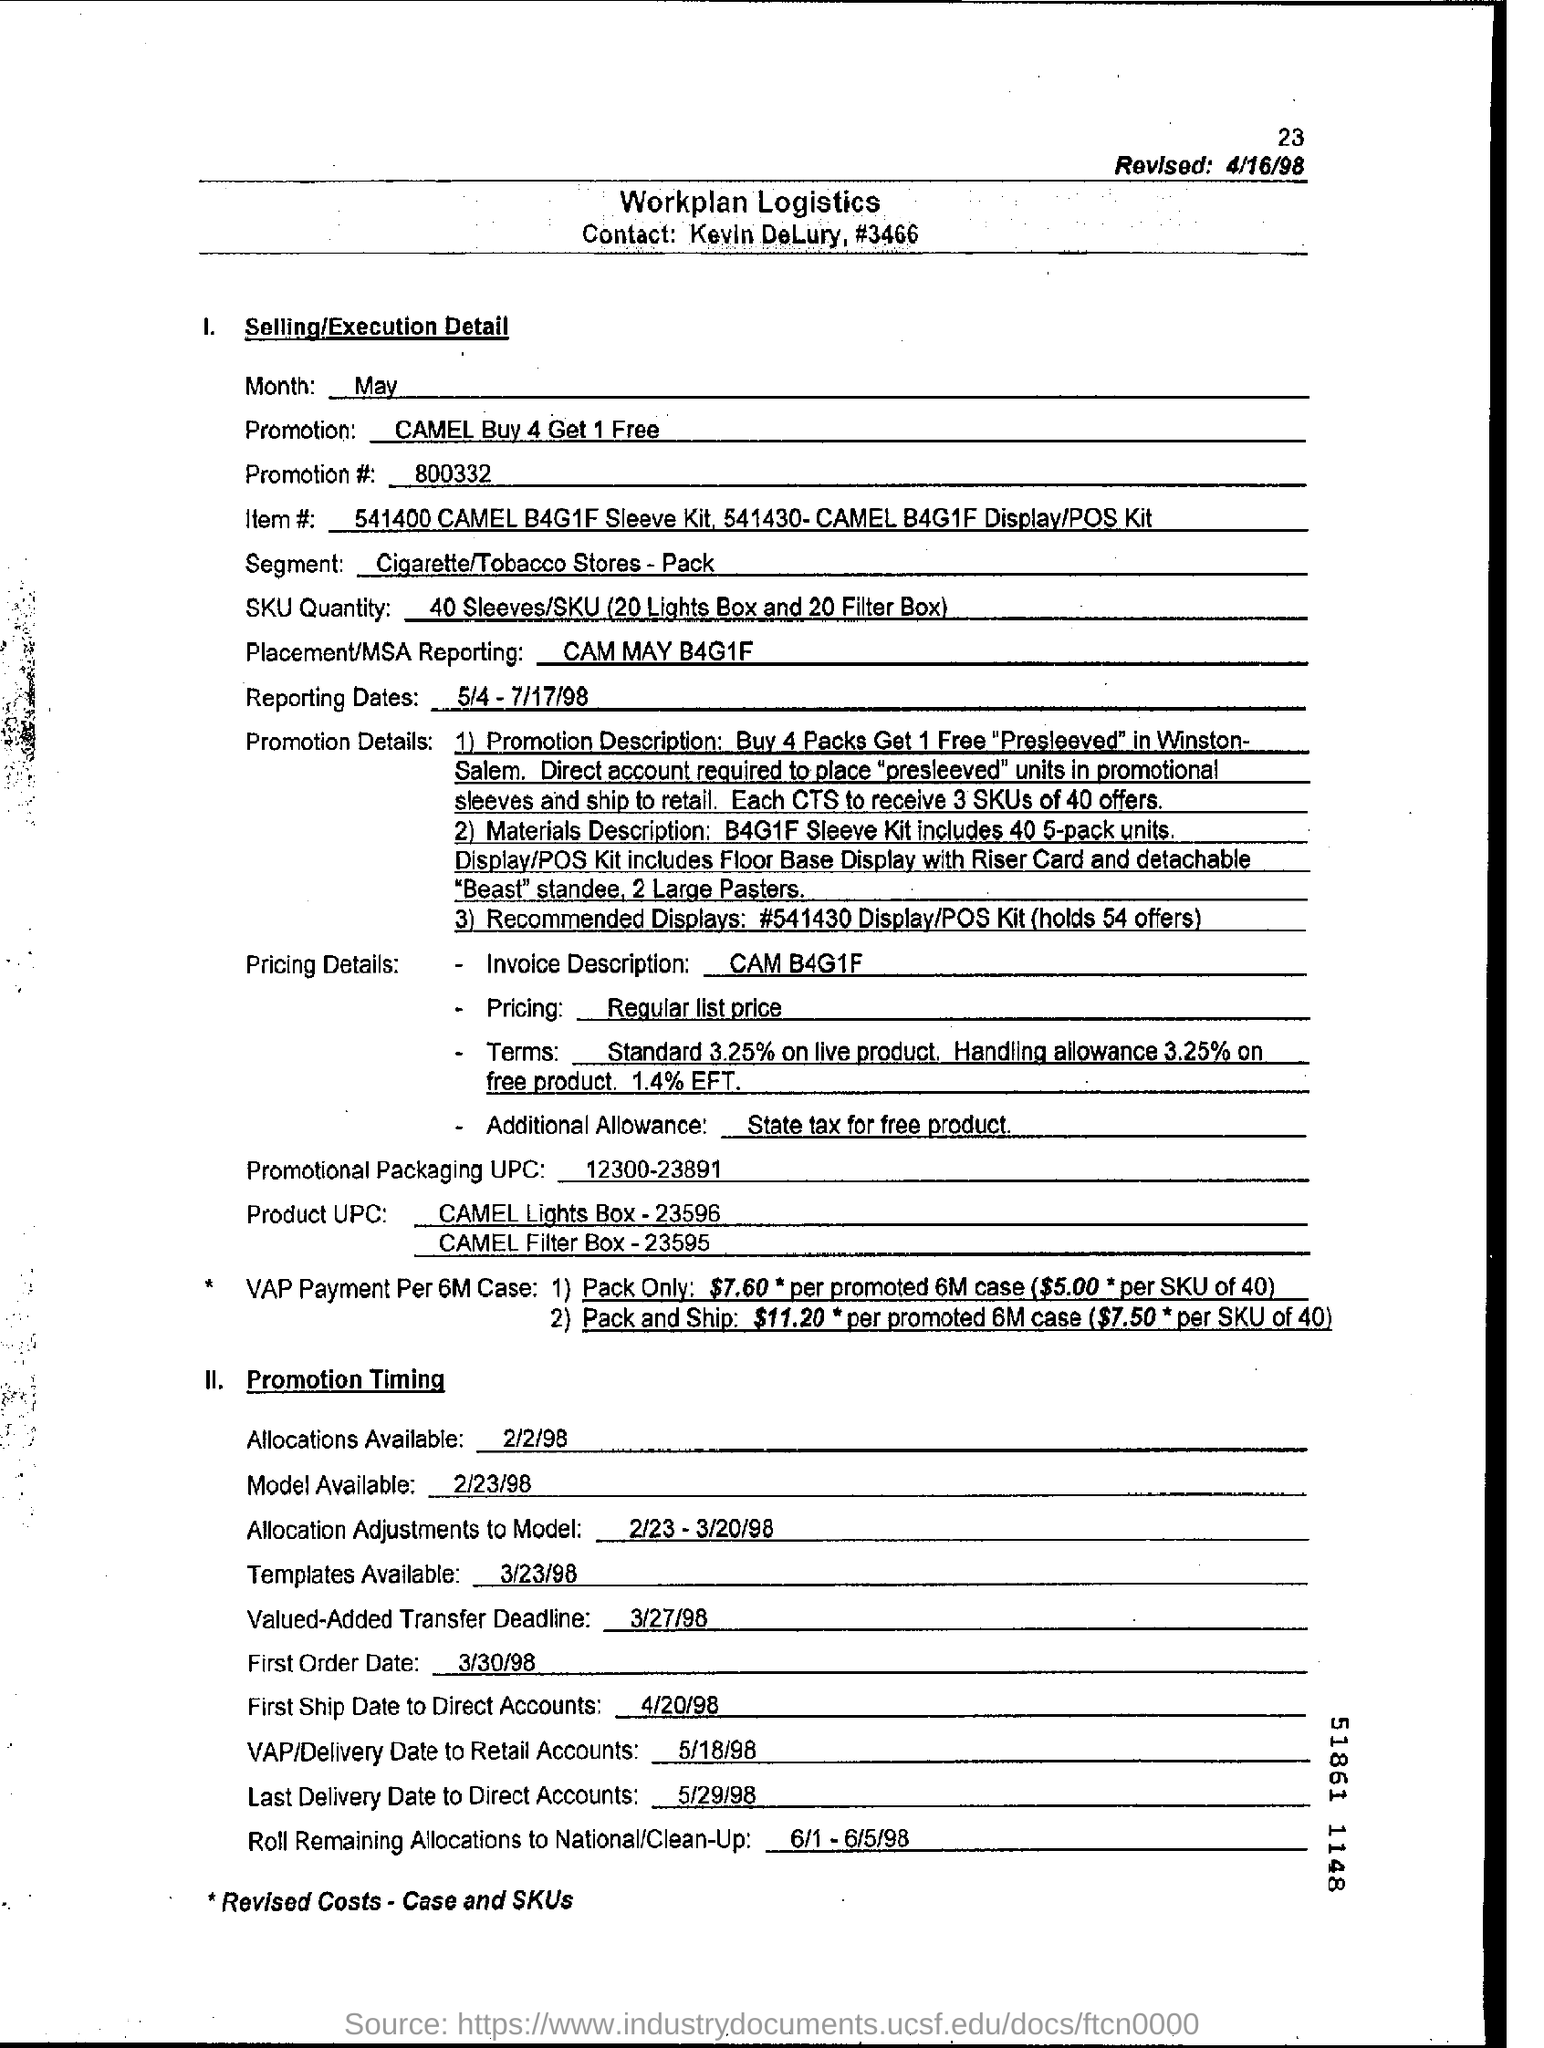Can you explain what the term 'Pre-sleeved' refers to in the context of this promotion? The term 'Pre-sleeved' in this promotion refers to the pre-packaging of products as part of the offer. This implies that the 4 packs purchased plus the free pack have already been grouped together for easy promotion and distribution. 